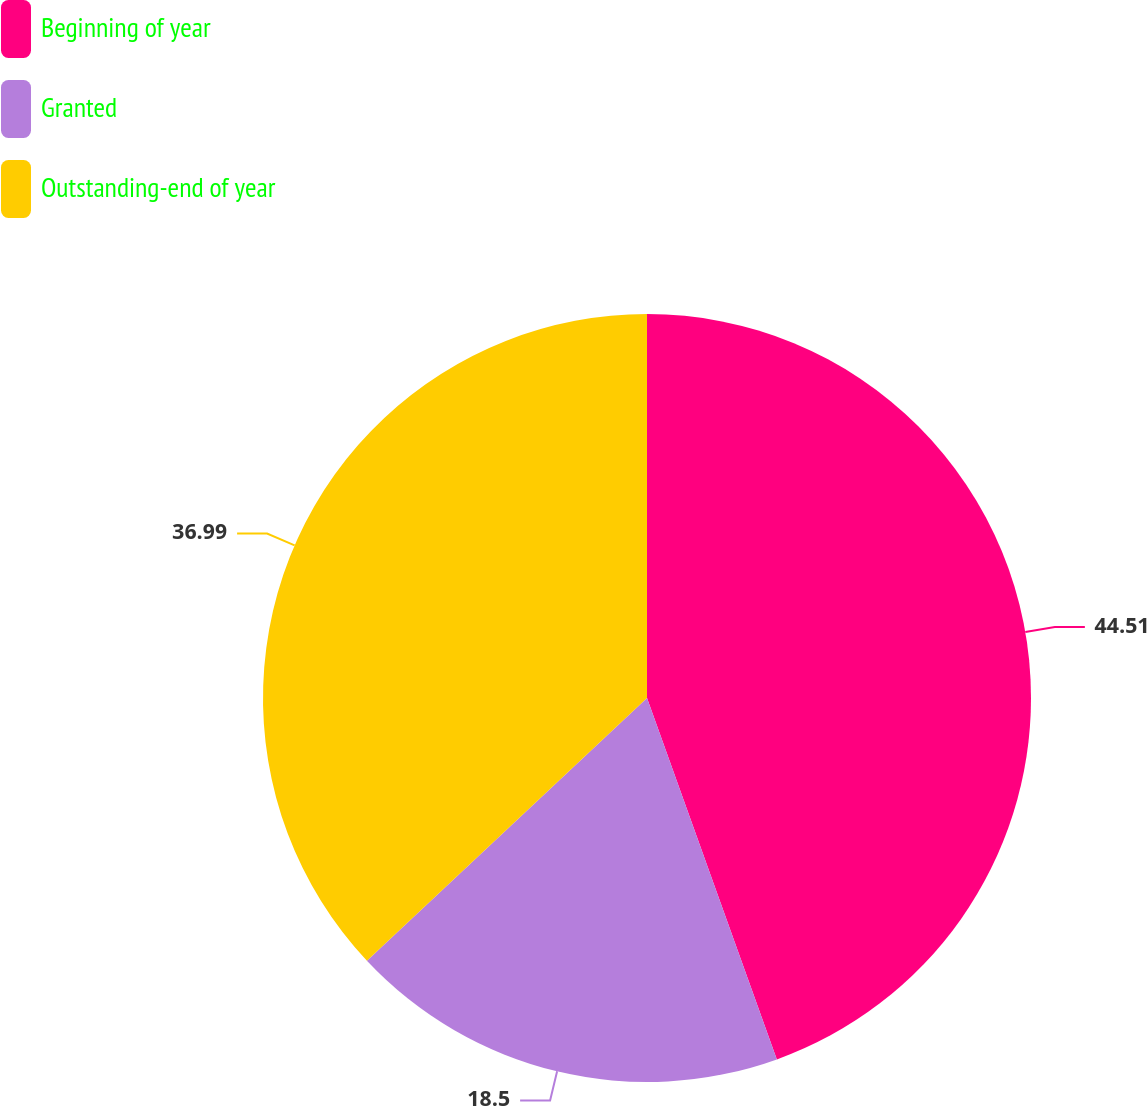<chart> <loc_0><loc_0><loc_500><loc_500><pie_chart><fcel>Beginning of year<fcel>Granted<fcel>Outstanding-end of year<nl><fcel>44.51%<fcel>18.5%<fcel>36.99%<nl></chart> 